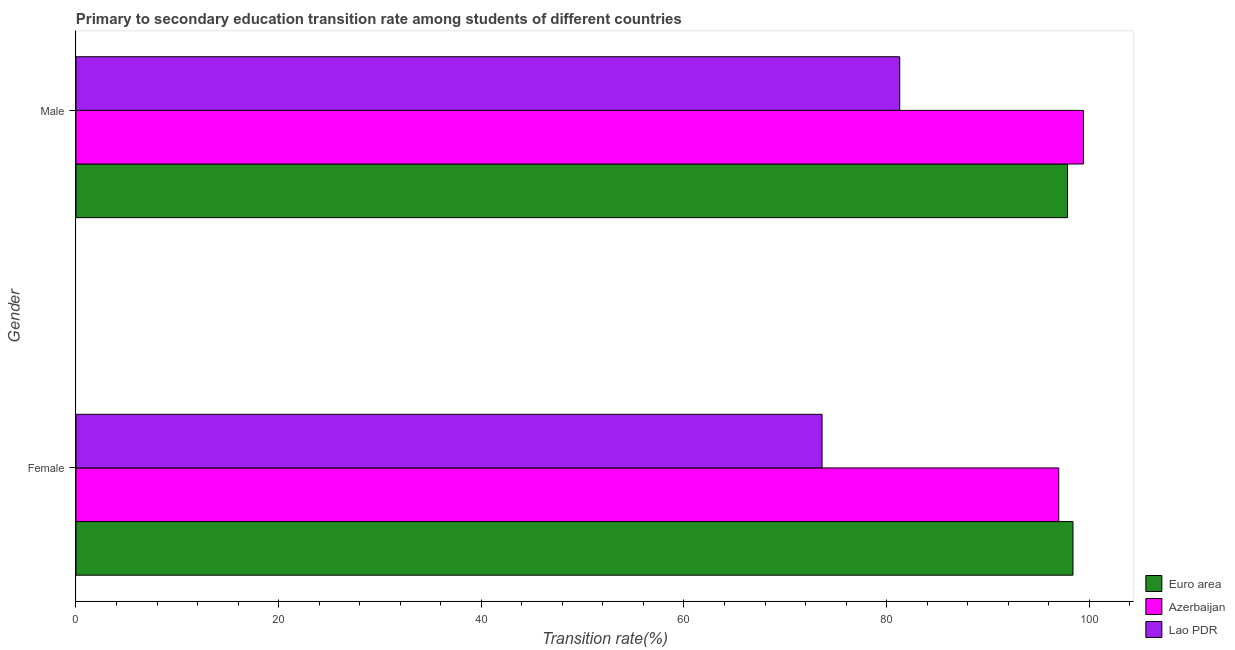How many different coloured bars are there?
Provide a succinct answer. 3. How many groups of bars are there?
Offer a terse response. 2. How many bars are there on the 2nd tick from the bottom?
Give a very brief answer. 3. What is the label of the 2nd group of bars from the top?
Your response must be concise. Female. What is the transition rate among female students in Azerbaijan?
Offer a terse response. 96.99. Across all countries, what is the maximum transition rate among male students?
Provide a succinct answer. 99.43. Across all countries, what is the minimum transition rate among female students?
Provide a succinct answer. 73.63. In which country was the transition rate among female students maximum?
Give a very brief answer. Euro area. In which country was the transition rate among male students minimum?
Offer a terse response. Lao PDR. What is the total transition rate among male students in the graph?
Make the answer very short. 278.59. What is the difference between the transition rate among female students in Euro area and that in Azerbaijan?
Keep it short and to the point. 1.41. What is the difference between the transition rate among female students in Azerbaijan and the transition rate among male students in Lao PDR?
Your answer should be compact. 15.7. What is the average transition rate among female students per country?
Provide a succinct answer. 89.67. What is the difference between the transition rate among male students and transition rate among female students in Lao PDR?
Your answer should be compact. 7.66. What is the ratio of the transition rate among male students in Lao PDR to that in Azerbaijan?
Your response must be concise. 0.82. In how many countries, is the transition rate among male students greater than the average transition rate among male students taken over all countries?
Your answer should be very brief. 2. What does the 1st bar from the top in Female represents?
Your answer should be compact. Lao PDR. What does the 3rd bar from the bottom in Female represents?
Your response must be concise. Lao PDR. How many bars are there?
Provide a succinct answer. 6. How many countries are there in the graph?
Ensure brevity in your answer.  3. Does the graph contain grids?
Your answer should be very brief. No. How many legend labels are there?
Make the answer very short. 3. What is the title of the graph?
Your answer should be very brief. Primary to secondary education transition rate among students of different countries. Does "China" appear as one of the legend labels in the graph?
Ensure brevity in your answer.  No. What is the label or title of the X-axis?
Your answer should be very brief. Transition rate(%). What is the Transition rate(%) of Euro area in Female?
Offer a very short reply. 98.4. What is the Transition rate(%) in Azerbaijan in Female?
Your answer should be very brief. 96.99. What is the Transition rate(%) of Lao PDR in Female?
Your answer should be very brief. 73.63. What is the Transition rate(%) of Euro area in Male?
Provide a short and direct response. 97.86. What is the Transition rate(%) in Azerbaijan in Male?
Make the answer very short. 99.43. What is the Transition rate(%) of Lao PDR in Male?
Make the answer very short. 81.3. Across all Gender, what is the maximum Transition rate(%) of Euro area?
Offer a very short reply. 98.4. Across all Gender, what is the maximum Transition rate(%) of Azerbaijan?
Your response must be concise. 99.43. Across all Gender, what is the maximum Transition rate(%) of Lao PDR?
Offer a very short reply. 81.3. Across all Gender, what is the minimum Transition rate(%) in Euro area?
Keep it short and to the point. 97.86. Across all Gender, what is the minimum Transition rate(%) of Azerbaijan?
Ensure brevity in your answer.  96.99. Across all Gender, what is the minimum Transition rate(%) in Lao PDR?
Provide a short and direct response. 73.63. What is the total Transition rate(%) in Euro area in the graph?
Ensure brevity in your answer.  196.26. What is the total Transition rate(%) in Azerbaijan in the graph?
Ensure brevity in your answer.  196.42. What is the total Transition rate(%) in Lao PDR in the graph?
Your answer should be very brief. 154.93. What is the difference between the Transition rate(%) of Euro area in Female and that in Male?
Give a very brief answer. 0.54. What is the difference between the Transition rate(%) in Azerbaijan in Female and that in Male?
Give a very brief answer. -2.44. What is the difference between the Transition rate(%) of Lao PDR in Female and that in Male?
Your response must be concise. -7.66. What is the difference between the Transition rate(%) of Euro area in Female and the Transition rate(%) of Azerbaijan in Male?
Your answer should be very brief. -1.03. What is the difference between the Transition rate(%) of Euro area in Female and the Transition rate(%) of Lao PDR in Male?
Provide a succinct answer. 17.1. What is the difference between the Transition rate(%) in Azerbaijan in Female and the Transition rate(%) in Lao PDR in Male?
Give a very brief answer. 15.7. What is the average Transition rate(%) of Euro area per Gender?
Provide a short and direct response. 98.13. What is the average Transition rate(%) in Azerbaijan per Gender?
Offer a very short reply. 98.21. What is the average Transition rate(%) in Lao PDR per Gender?
Your response must be concise. 77.46. What is the difference between the Transition rate(%) of Euro area and Transition rate(%) of Azerbaijan in Female?
Your answer should be compact. 1.41. What is the difference between the Transition rate(%) of Euro area and Transition rate(%) of Lao PDR in Female?
Make the answer very short. 24.76. What is the difference between the Transition rate(%) in Azerbaijan and Transition rate(%) in Lao PDR in Female?
Provide a succinct answer. 23.36. What is the difference between the Transition rate(%) in Euro area and Transition rate(%) in Azerbaijan in Male?
Make the answer very short. -1.57. What is the difference between the Transition rate(%) in Euro area and Transition rate(%) in Lao PDR in Male?
Your response must be concise. 16.57. What is the difference between the Transition rate(%) in Azerbaijan and Transition rate(%) in Lao PDR in Male?
Provide a short and direct response. 18.13. What is the ratio of the Transition rate(%) in Azerbaijan in Female to that in Male?
Provide a succinct answer. 0.98. What is the ratio of the Transition rate(%) of Lao PDR in Female to that in Male?
Your answer should be compact. 0.91. What is the difference between the highest and the second highest Transition rate(%) in Euro area?
Keep it short and to the point. 0.54. What is the difference between the highest and the second highest Transition rate(%) of Azerbaijan?
Keep it short and to the point. 2.44. What is the difference between the highest and the second highest Transition rate(%) in Lao PDR?
Offer a very short reply. 7.66. What is the difference between the highest and the lowest Transition rate(%) in Euro area?
Your response must be concise. 0.54. What is the difference between the highest and the lowest Transition rate(%) of Azerbaijan?
Give a very brief answer. 2.44. What is the difference between the highest and the lowest Transition rate(%) of Lao PDR?
Your response must be concise. 7.66. 